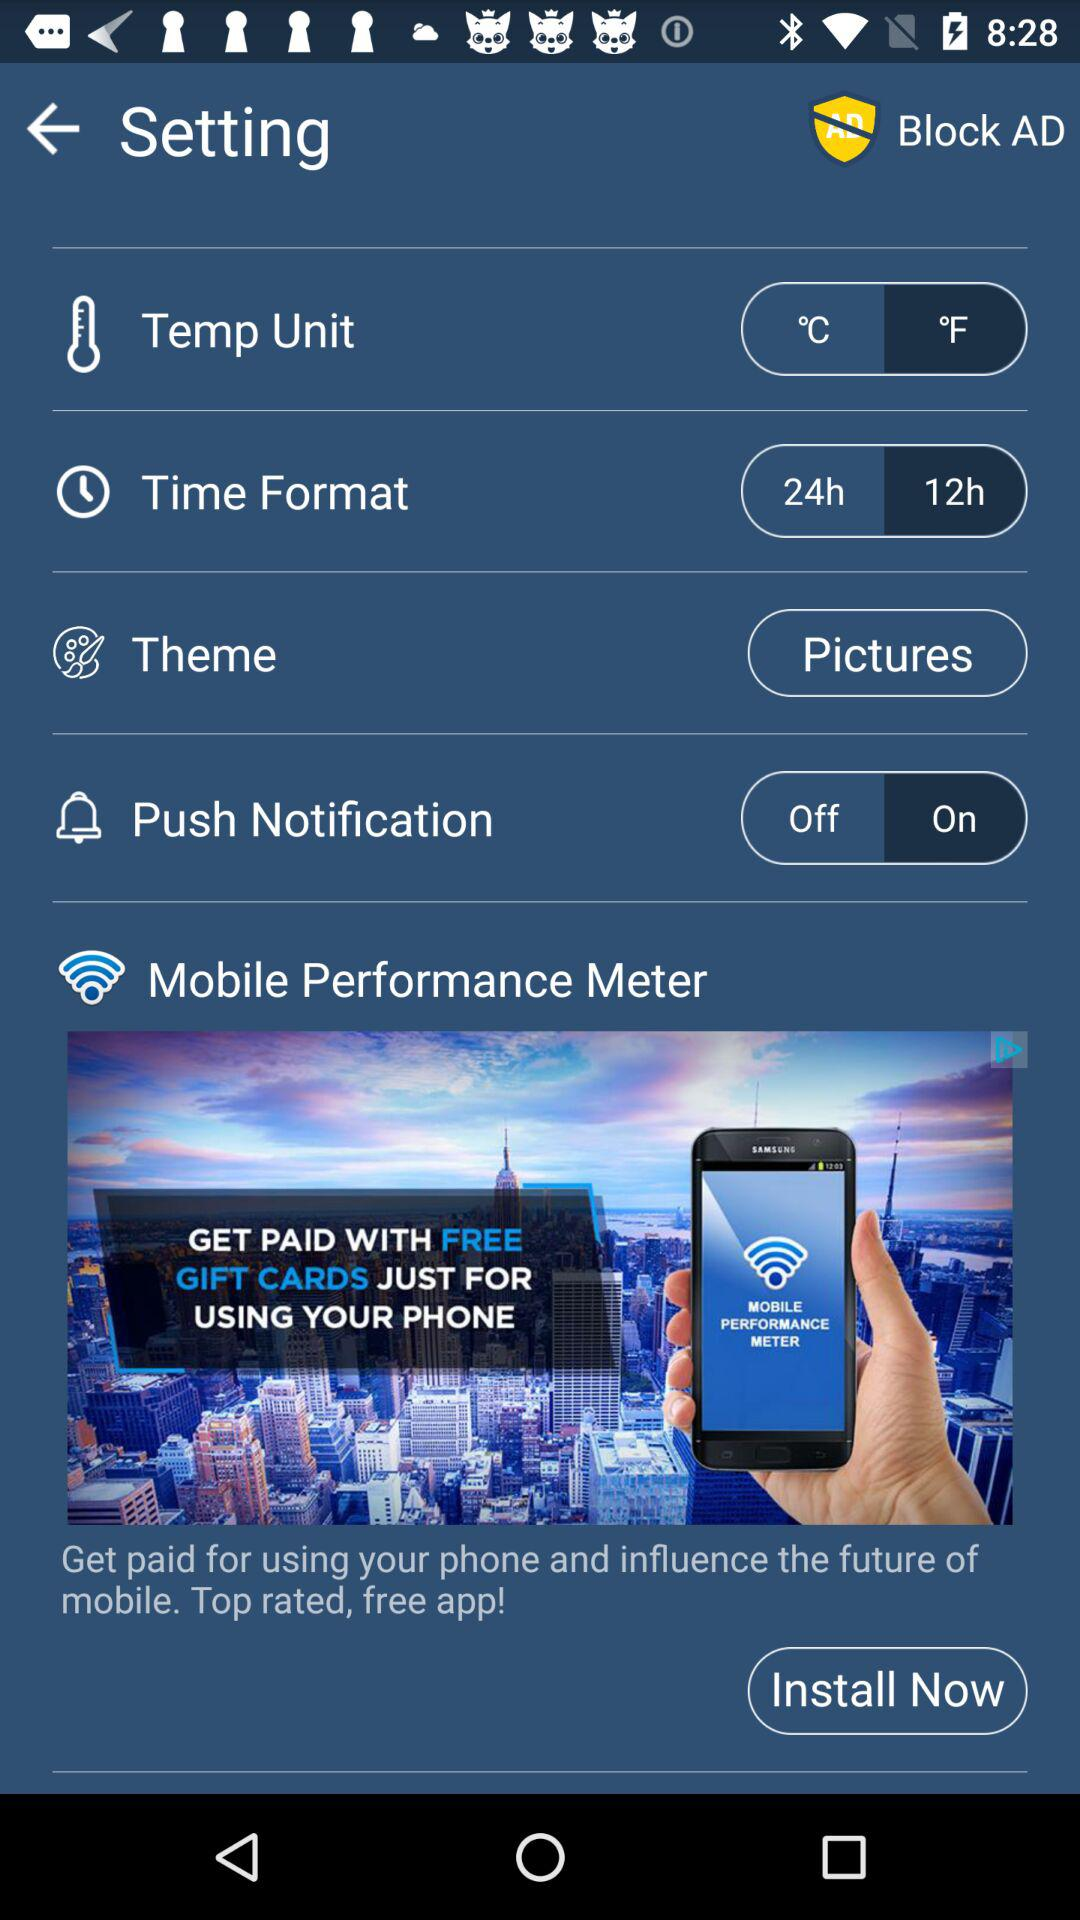What is the status of "Push Notification"? The status is "on". 